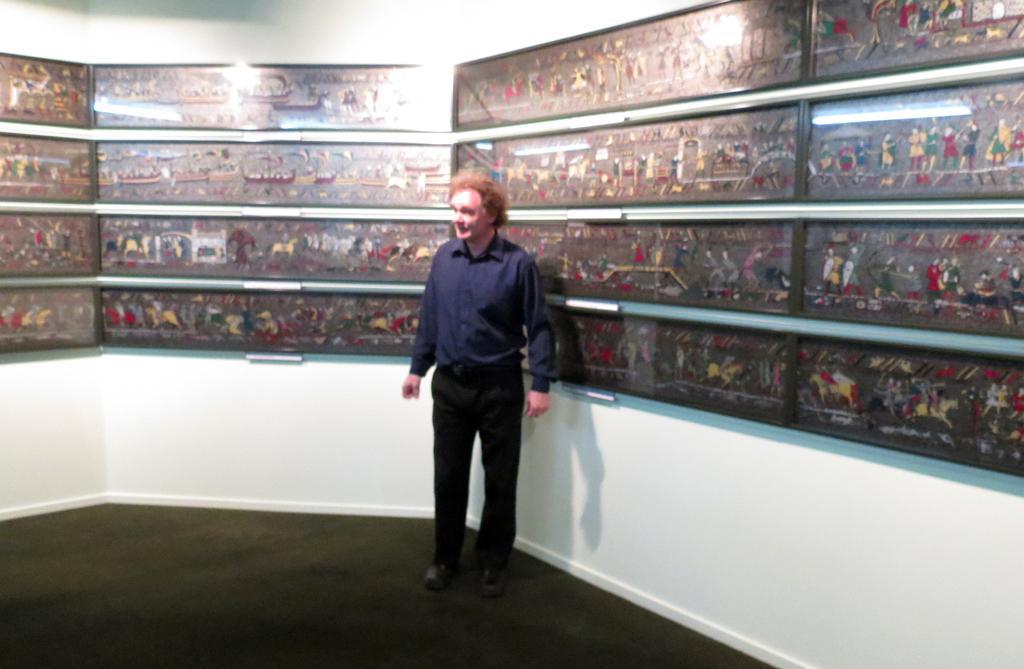Please provide a concise description of this image. This picture is clicked outside the room. Man in blue shirt and black pant is standing in a room. Behind him, we see a white wall on which many frames are placed on the wall. 